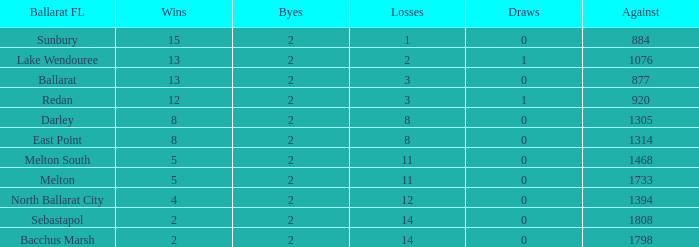How many Against has a Ballarat FL of darley and Wins larger than 8? 0.0. 